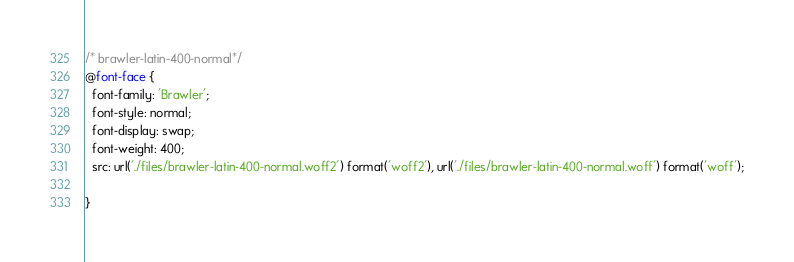Convert code to text. <code><loc_0><loc_0><loc_500><loc_500><_CSS_>/* brawler-latin-400-normal*/
@font-face {
  font-family: 'Brawler';
  font-style: normal;
  font-display: swap;
  font-weight: 400;
  src: url('./files/brawler-latin-400-normal.woff2') format('woff2'), url('./files/brawler-latin-400-normal.woff') format('woff');
  
}
</code> 